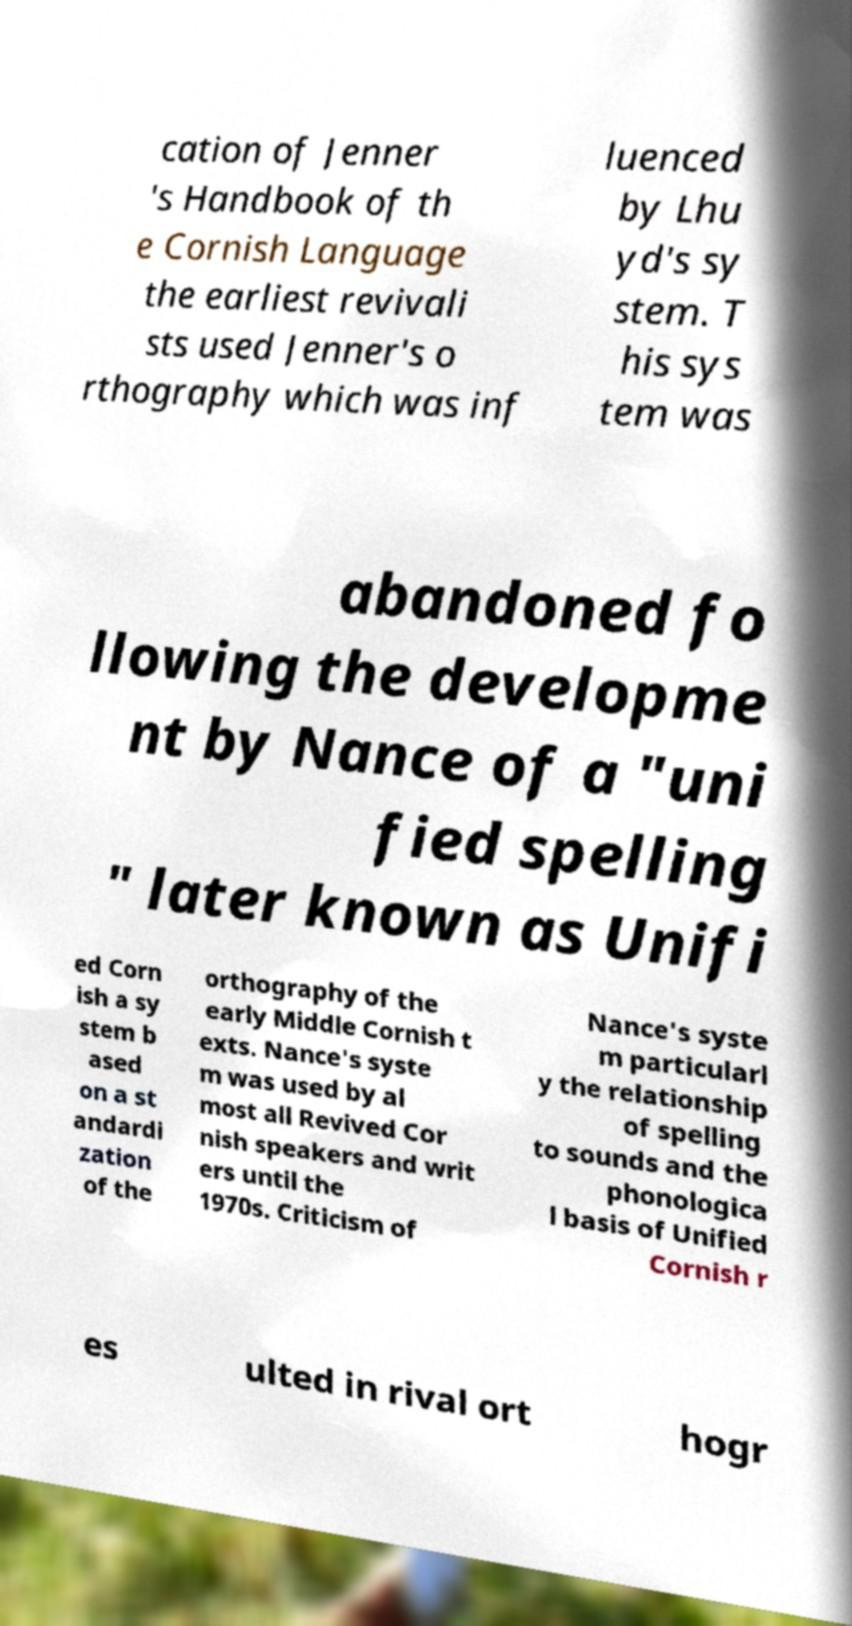There's text embedded in this image that I need extracted. Can you transcribe it verbatim? cation of Jenner 's Handbook of th e Cornish Language the earliest revivali sts used Jenner's o rthography which was inf luenced by Lhu yd's sy stem. T his sys tem was abandoned fo llowing the developme nt by Nance of a "uni fied spelling " later known as Unifi ed Corn ish a sy stem b ased on a st andardi zation of the orthography of the early Middle Cornish t exts. Nance's syste m was used by al most all Revived Cor nish speakers and writ ers until the 1970s. Criticism of Nance's syste m particularl y the relationship of spelling to sounds and the phonologica l basis of Unified Cornish r es ulted in rival ort hogr 